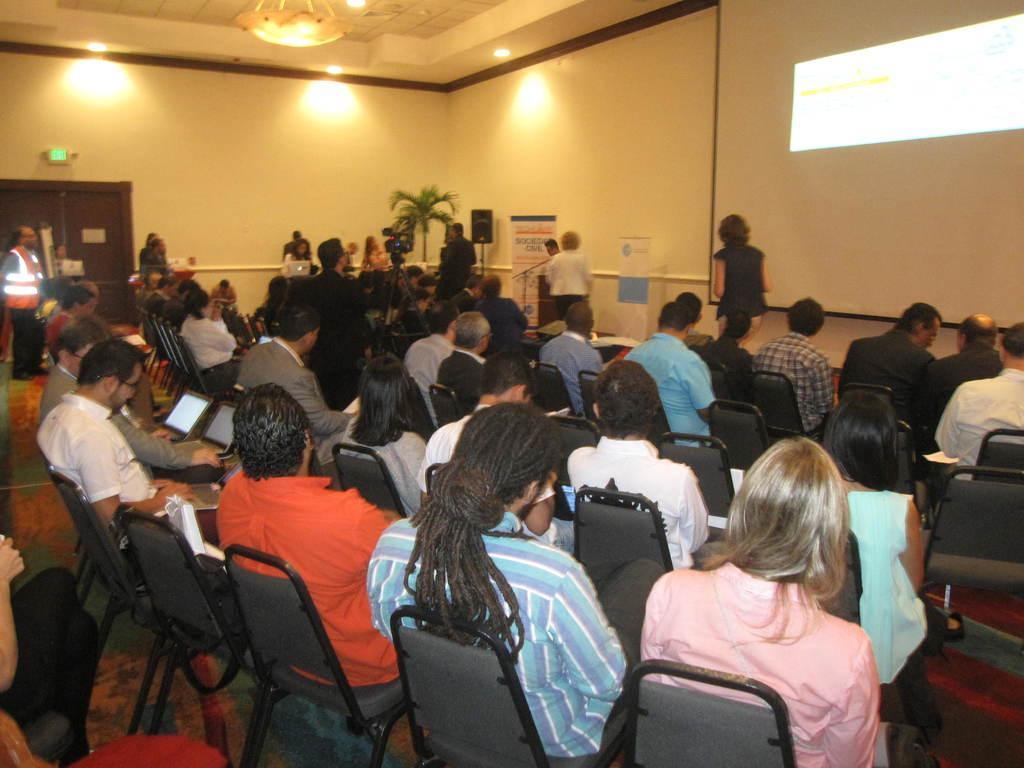Please provide a concise description of this image. In this image I can see number of persons are sitting on chairs which are grey and black in color. I can see few laptops in their laps. In the background I can see few persons standing, the wall, the ceiling, few lights to the ceiling, a camera and a chandelier. I can see the brown colored door. 